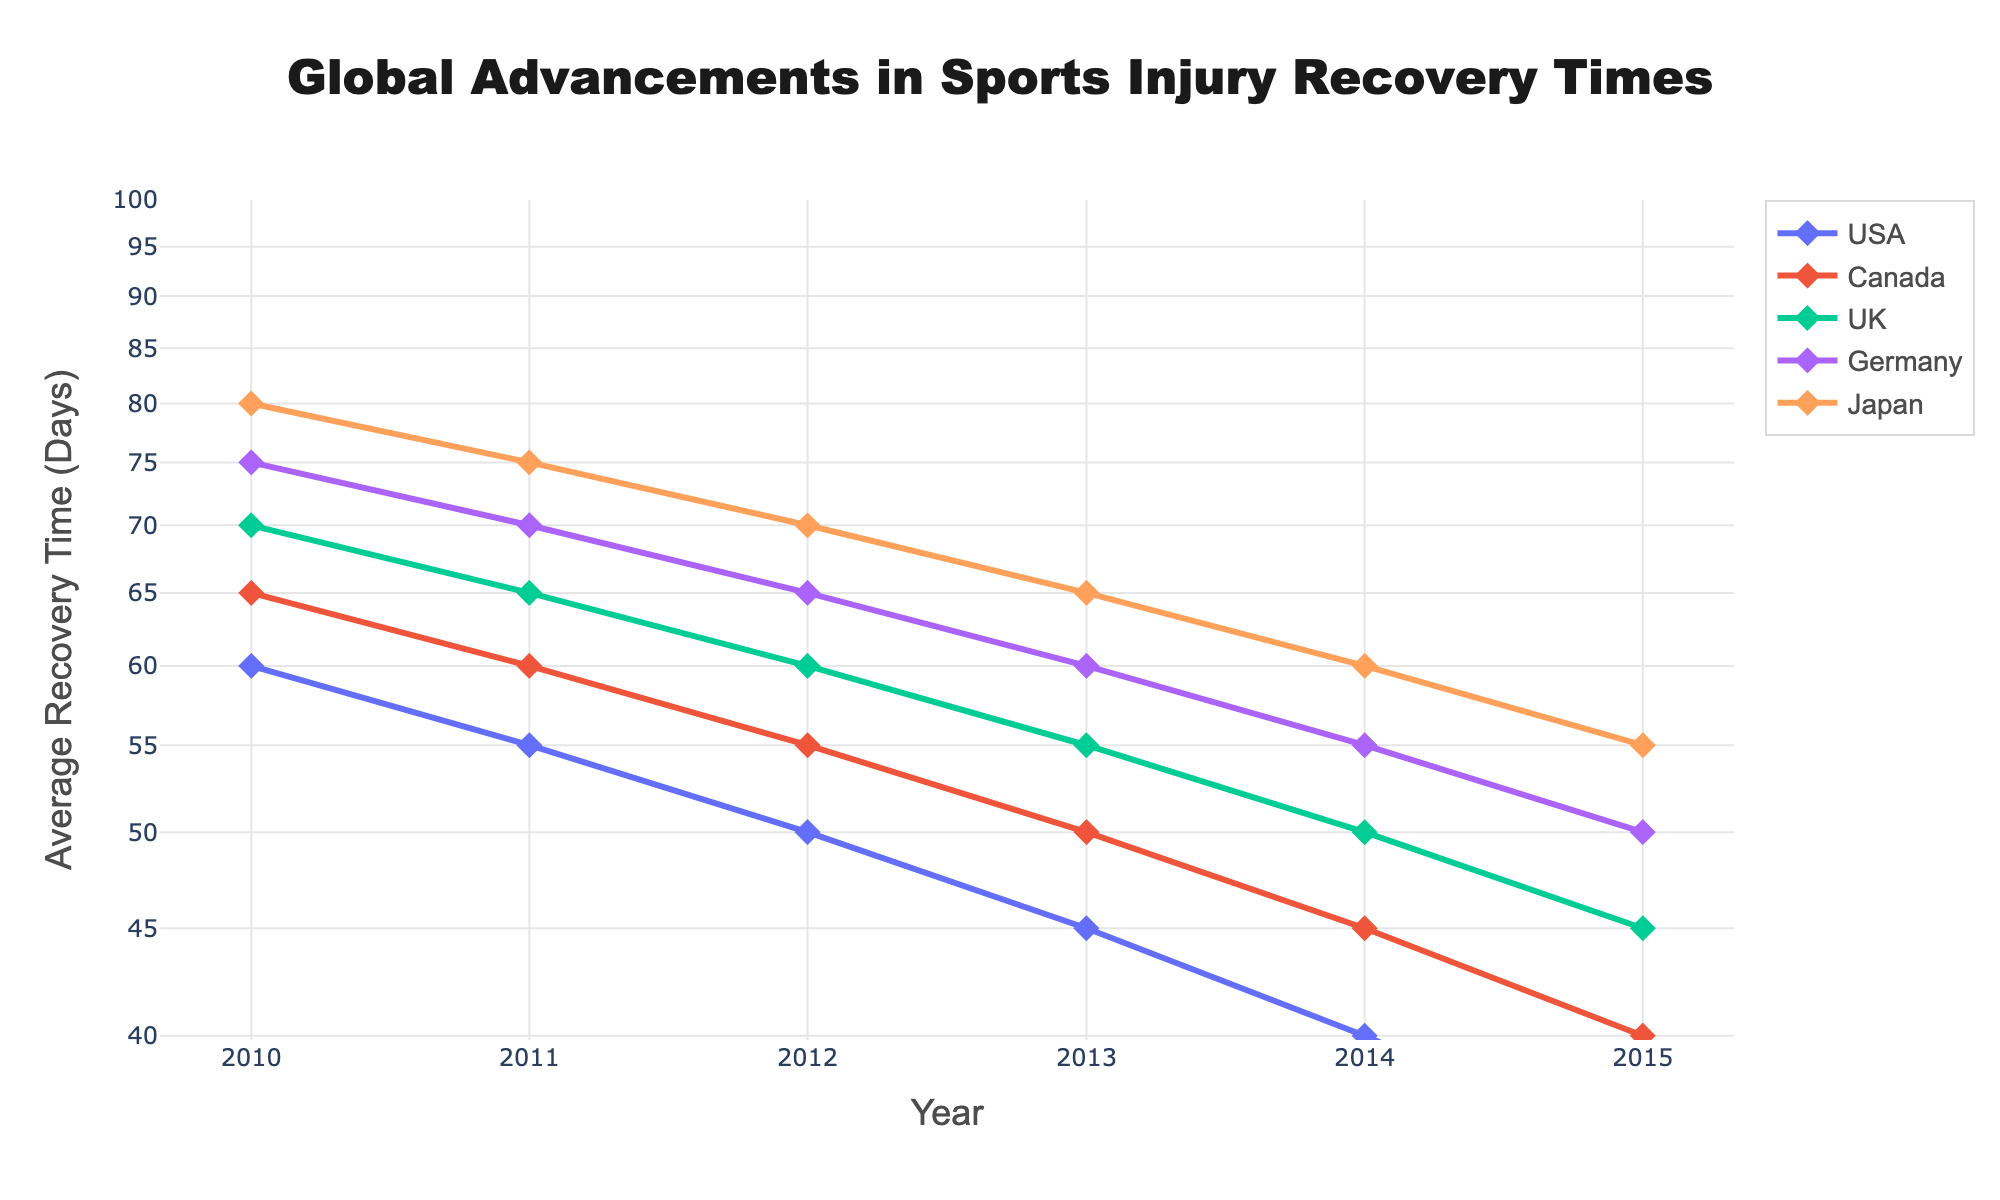What is the title of the plot? The title is located at the top center of the plot. Reading it directly reveals the title.
Answer: Global Advancements in Sports Injury Recovery Times What year shows the shortest recovery time for USA? Look at the data points for the USA and find the lowest value on the y-axis. Note the corresponding year on the x-axis for this point.
Answer: 2015 How does the recovery time in Japan change from 2010 to 2015? Identify Japan's line, then observe the data points from 2010 to 2015. Note how the y-values decrease over these years.
Answer: Decreased from 80 to 55 days Which country had the longest recovery time in 2013? Compare the y-values for all countries in 2013. The highest y-value indicates the longest recovery time.
Answer: Japan How much did the average recovery time decrease in Germany from 2010 to 2015? For Germany, find the recovery times for 2010 and 2015. Calculate the difference between these two values.
Answer: 25 days What rehabilitation technique was associated with the recovery time of 45 days in the UK in 2013? Look at the UK's data point in 2013 and note its y-value. Refer back to the original data for this value to find the corresponding rehabilitation technique.
Answer: Physical Therapy with Laser Therapy Which country shows a constant recovery time decrease over the years? Observe the pattern of the lines for each country. The country with a consistent downward trend in the recovery times is the answer.
Answer: All countries In which year did Canada first achieve a recovery time below 50 days? For Canada, find the first year with a y-value under 50. This is found by examining each year's data point.
Answer: 2014 Did the introduction of PRP Injections result in an average recovery time of less than 50 days for any country? PRP Injections are introduced in 2015 for all countries. Check if any country's 2015 recovery time is under 50 days.
Answer: Yes, for USA How does the trend in recovery times for the UK compare to the trend for the USA? Compare the lines for the UK and the USA over the years. Evaluate if they follow a similar downward trend or differ.
Answer: Both show a decreasing trend, but the USA decreases slightly faster 